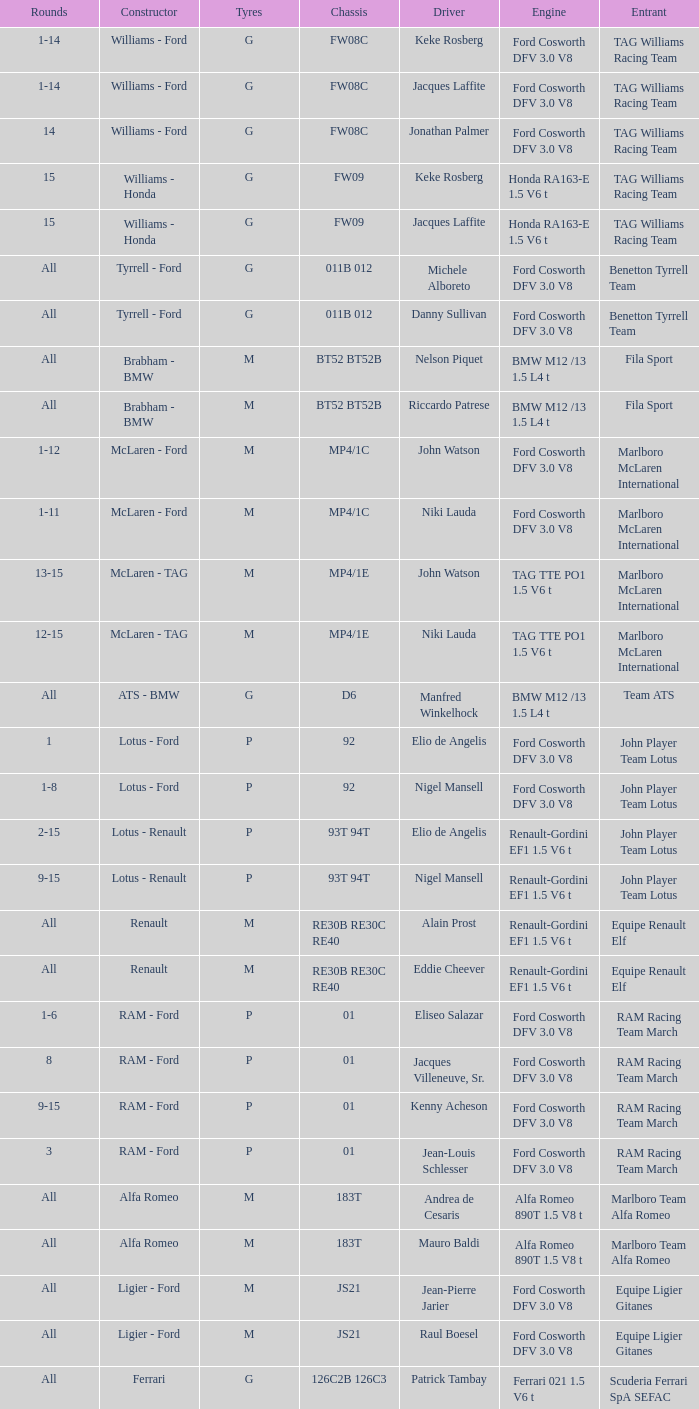Who is the constructor for driver Niki Lauda and a chassis of mp4/1c? McLaren - Ford. 